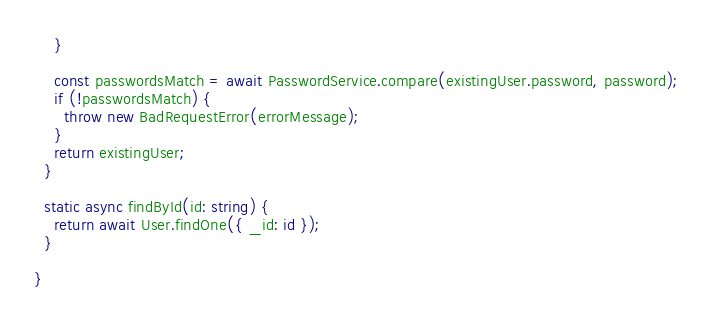<code> <loc_0><loc_0><loc_500><loc_500><_TypeScript_>    }

    const passwordsMatch = await PasswordService.compare(existingUser.password, password);
    if (!passwordsMatch) {
      throw new BadRequestError(errorMessage);
    }
    return existingUser;
  }

  static async findById(id: string) {
    return await User.findOne({ _id: id });
  }

}</code> 